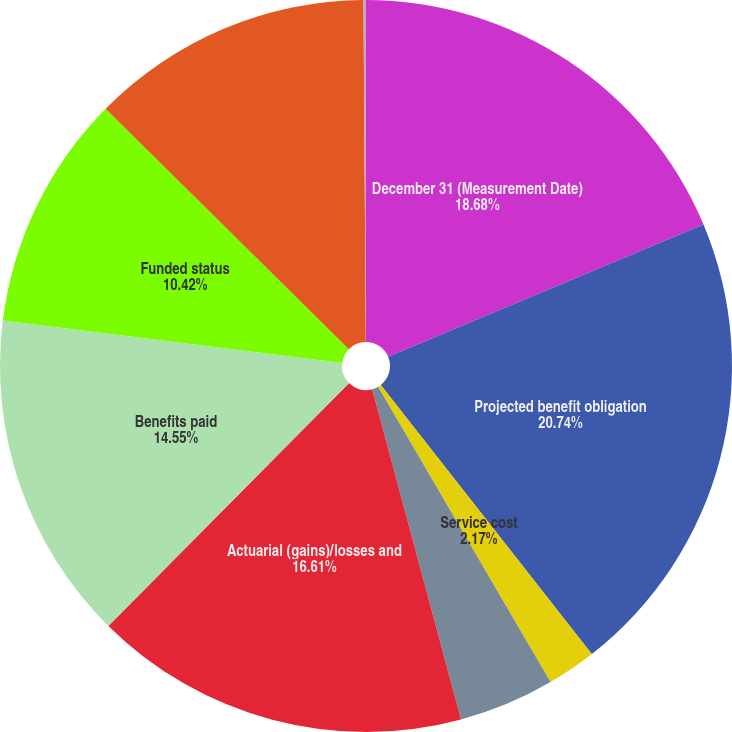<chart> <loc_0><loc_0><loc_500><loc_500><pie_chart><fcel>December 31 (Measurement Date)<fcel>Projected benefit obligation<fcel>Service cost<fcel>Interest cost<fcel>Actuarial (gains)/losses and<fcel>Benefits paid<fcel>Funded status<fcel>Net amount recognized on the<fcel>Prior service cost (credit)<nl><fcel>18.68%<fcel>20.74%<fcel>2.17%<fcel>4.23%<fcel>16.61%<fcel>14.55%<fcel>10.42%<fcel>12.49%<fcel>0.11%<nl></chart> 